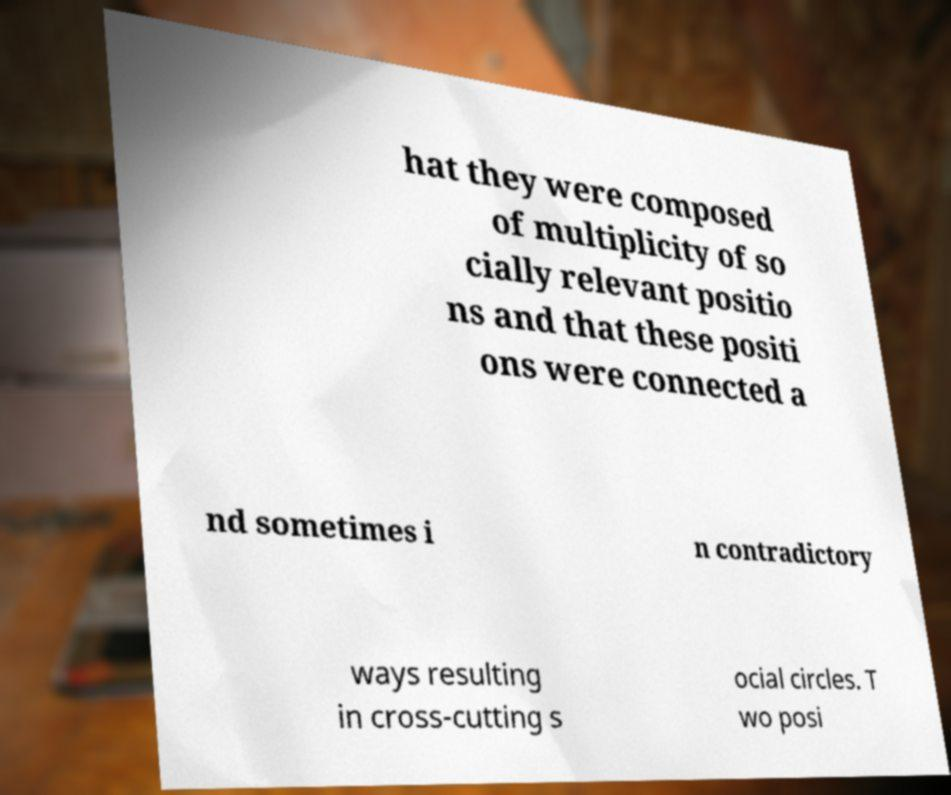Could you assist in decoding the text presented in this image and type it out clearly? hat they were composed of multiplicity of so cially relevant positio ns and that these positi ons were connected a nd sometimes i n contradictory ways resulting in cross-cutting s ocial circles. T wo posi 